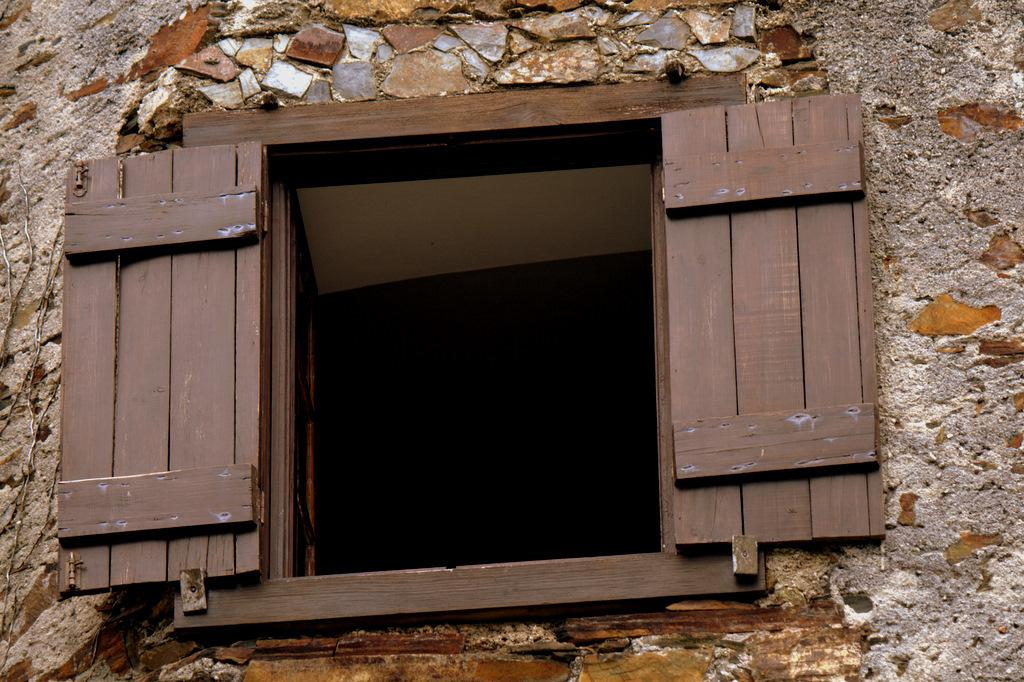What type of structure can be seen in the image? There is a wall in the image. What is the color and material of the window in the image? The window is brown-colored and made of wood. Does the wooden window have any additional features? Yes, the wooden window has doors. How many different types of roads are visible in the image? There are no roads visible in the image; it only features a wall and a wooden window with doors. 